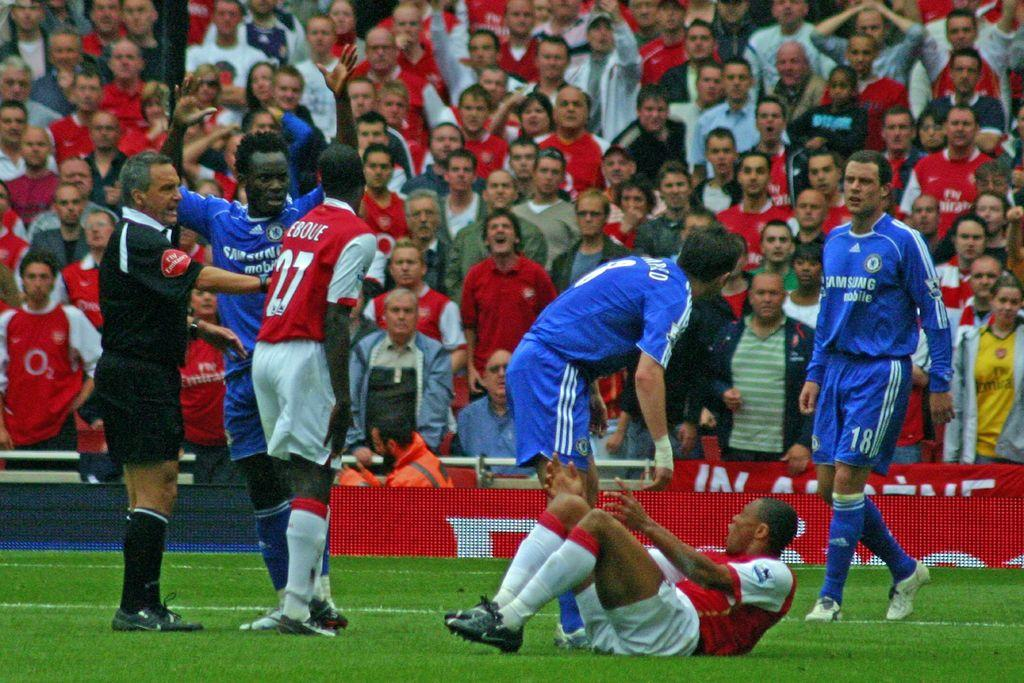<image>
Present a compact description of the photo's key features. a soccer field with one of the players wearing number 18 